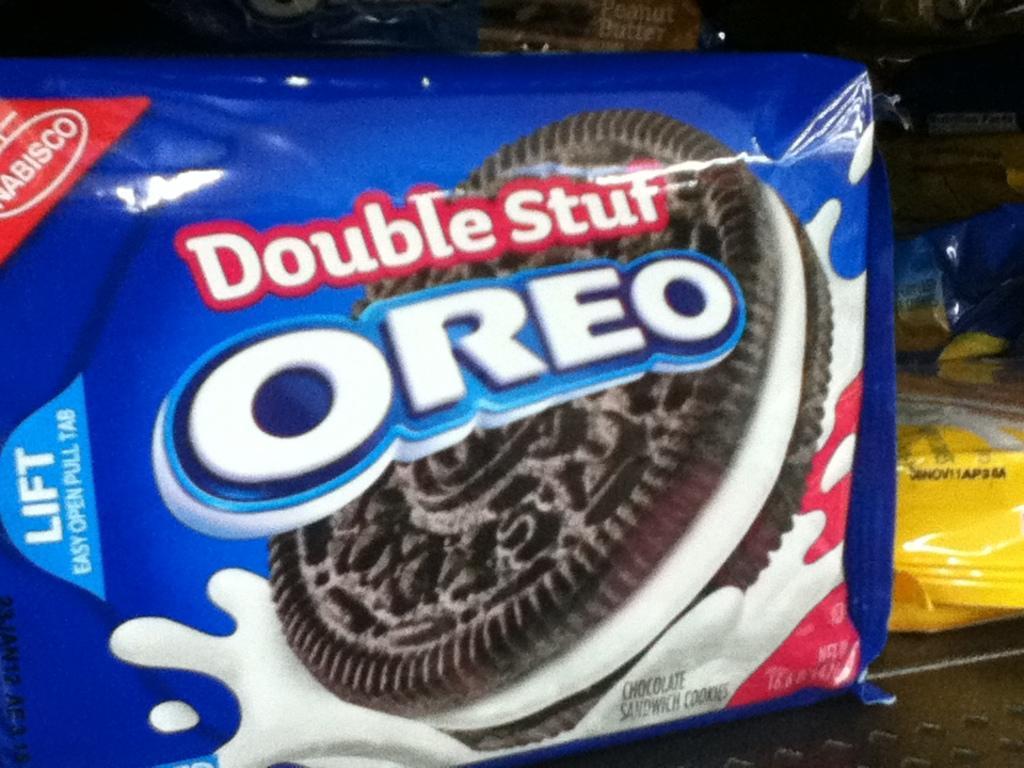In one or two sentences, can you explain what this image depicts? In this image we can see two Oreo biscuit packets on the surface and some other objects are on the surface. 